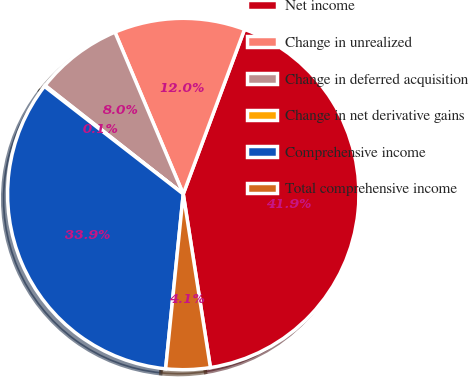Convert chart to OTSL. <chart><loc_0><loc_0><loc_500><loc_500><pie_chart><fcel>Net income<fcel>Change in unrealized<fcel>Change in deferred acquisition<fcel>Change in net derivative gains<fcel>Comprehensive income<fcel>Total comprehensive income<nl><fcel>41.86%<fcel>12.03%<fcel>8.05%<fcel>0.1%<fcel>33.9%<fcel>4.07%<nl></chart> 